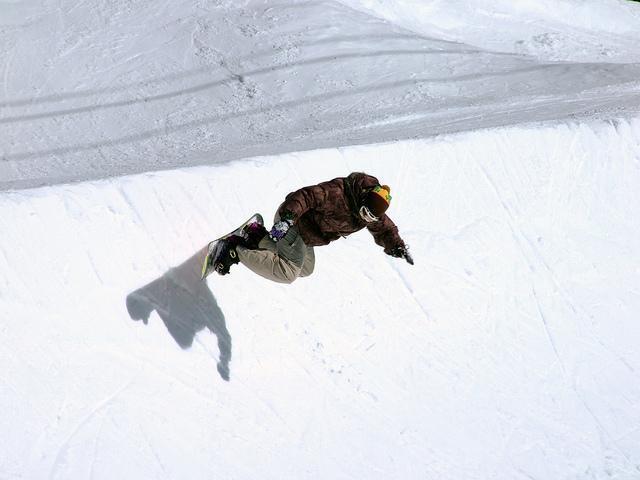How many suitcases are in the photo?
Give a very brief answer. 0. 